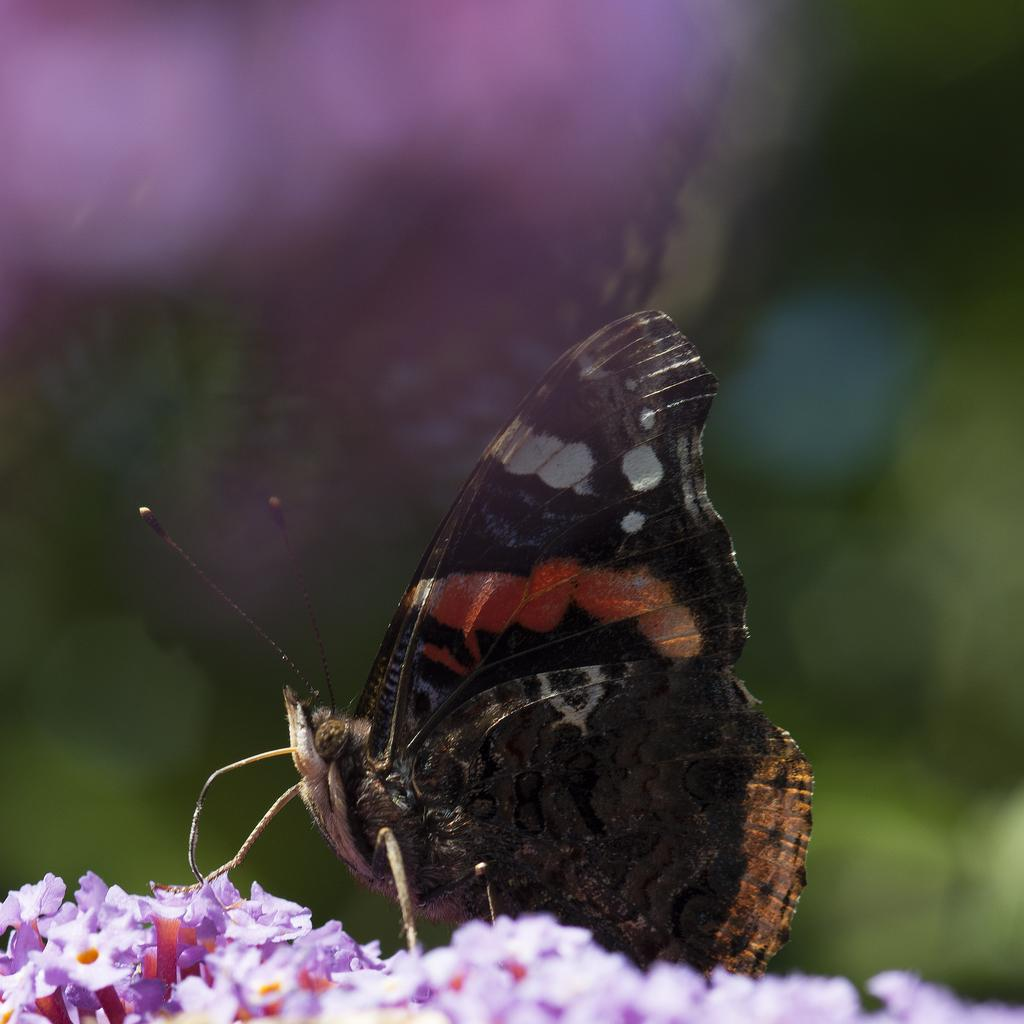What type of flowers can be seen in the image? There are purple flowers in the image. Are there any other living organisms visible in the image? Yes, there is a black insect in the image. How would you describe the overall clarity of the image? The image is blurry in the background. What type of feather can be seen in the image? There is no feather present in the image. What is the drawer used for in the image? There is no drawer present in the image. 